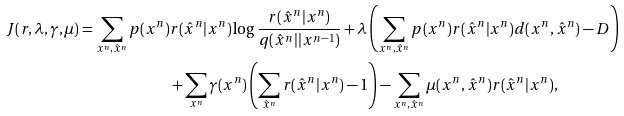Convert formula to latex. <formula><loc_0><loc_0><loc_500><loc_500>J ( r , \lambda , \gamma , \mu ) = \sum _ { x ^ { n } , \hat { x } ^ { n } } p ( x ^ { n } ) & r ( \hat { x } ^ { n } | x ^ { n } ) \log \frac { r ( \hat { x } ^ { n } | x ^ { n } ) } { q ( \hat { x } ^ { n } | | x ^ { n - 1 } ) } + \lambda \left ( \sum _ { x ^ { n } , \hat { x } ^ { n } } p ( x ^ { n } ) r ( \hat { x } ^ { n } | x ^ { n } ) d ( x ^ { n } , \hat { x } ^ { n } ) - D \right ) \\ & + \sum _ { x ^ { n } } \gamma ( x ^ { n } ) \left ( \sum _ { \hat { x } ^ { n } } r ( \hat { x } ^ { n } | x ^ { n } ) - 1 \right ) - \sum _ { x ^ { n } , \hat { x } ^ { n } } \mu ( x ^ { n } , \hat { x } ^ { n } ) r ( \hat { x } ^ { n } | x ^ { n } ) ,</formula> 